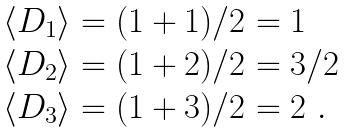Convert formula to latex. <formula><loc_0><loc_0><loc_500><loc_500>\begin{array} { l } \langle D _ { 1 } \rangle = ( 1 + 1 ) / 2 = 1 \\ \langle D _ { 2 } \rangle = ( 1 + 2 ) / 2 = 3 / 2 \\ \langle D _ { 3 } \rangle = ( 1 + 3 ) / 2 = 2 \ . \end{array}</formula> 